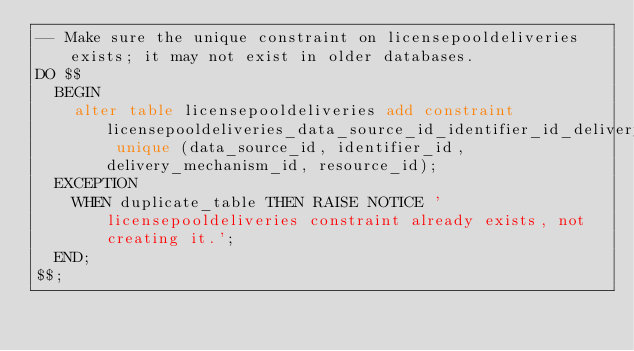<code> <loc_0><loc_0><loc_500><loc_500><_SQL_>-- Make sure the unique constraint on licensepooldeliveries exists; it may not exist in older databases.
DO $$
  BEGIN
    alter table licensepooldeliveries add constraint licensepooldeliveries_data_source_id_identifier_id_delivery_key unique (data_source_id, identifier_id, delivery_mechanism_id, resource_id);
  EXCEPTION
    WHEN duplicate_table THEN RAISE NOTICE 'licensepooldeliveries constraint already exists, not creating it.';
  END;
$$;
</code> 